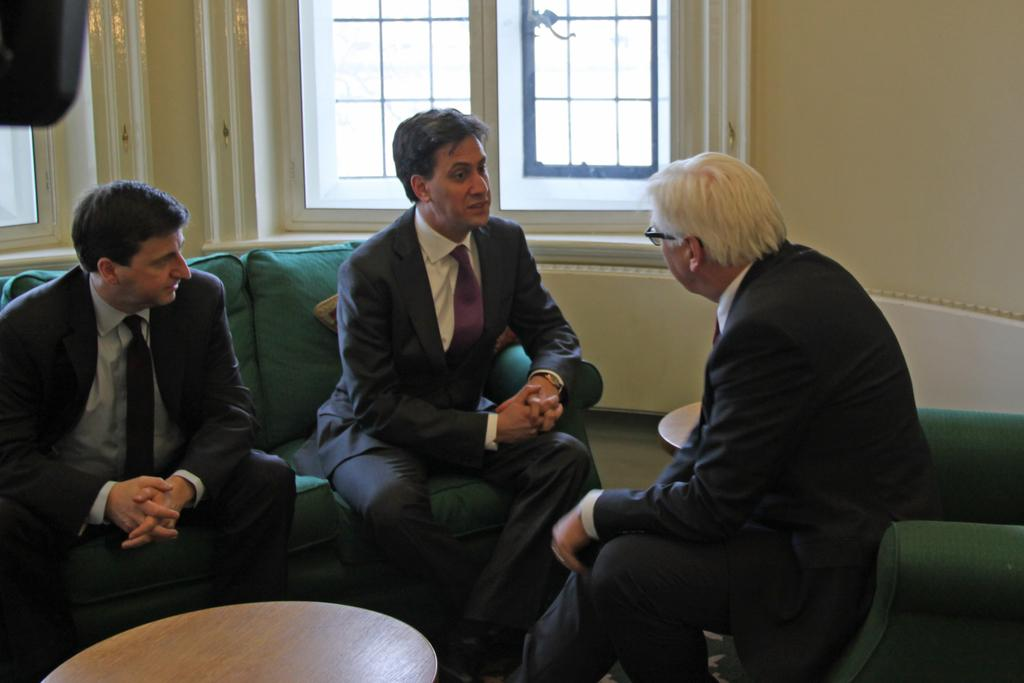How many people are in the image? There are three men in the image. What are the men doing in the image? The men are sitting on a green chair. What is located to the left of the chair? There is a wooden table to the left of the chair. What type of arithmetic problem can be solved using the scale in the image? There is no scale present in the image, so it is not possible to solve any arithmetic problems using it. 